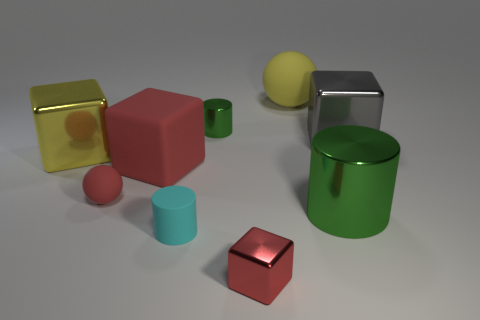Add 1 tiny cyan matte cylinders. How many objects exist? 10 Subtract all spheres. How many objects are left? 7 Subtract all brown rubber blocks. Subtract all tiny green cylinders. How many objects are left? 8 Add 9 tiny spheres. How many tiny spheres are left? 10 Add 8 big gray matte spheres. How many big gray matte spheres exist? 8 Subtract 1 yellow balls. How many objects are left? 8 